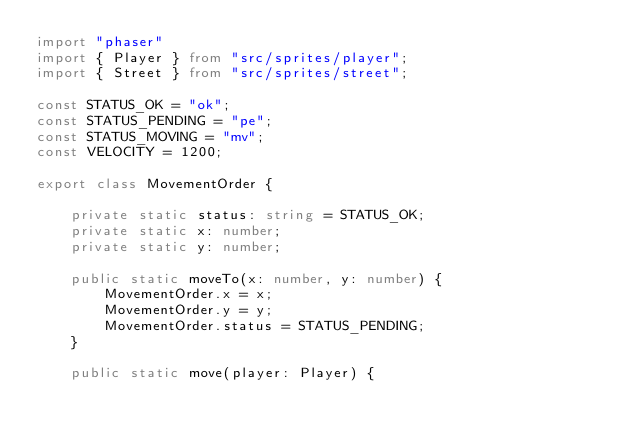<code> <loc_0><loc_0><loc_500><loc_500><_TypeScript_>import "phaser"
import { Player } from "src/sprites/player";
import { Street } from "src/sprites/street";

const STATUS_OK = "ok";
const STATUS_PENDING = "pe";
const STATUS_MOVING = "mv";
const VELOCITY = 1200;

export class MovementOrder {

    private static status: string = STATUS_OK;
    private static x: number;
    private static y: number;

    public static moveTo(x: number, y: number) {
        MovementOrder.x = x;
        MovementOrder.y = y;
        MovementOrder.status = STATUS_PENDING;
    }

    public static move(player: Player) {</code> 